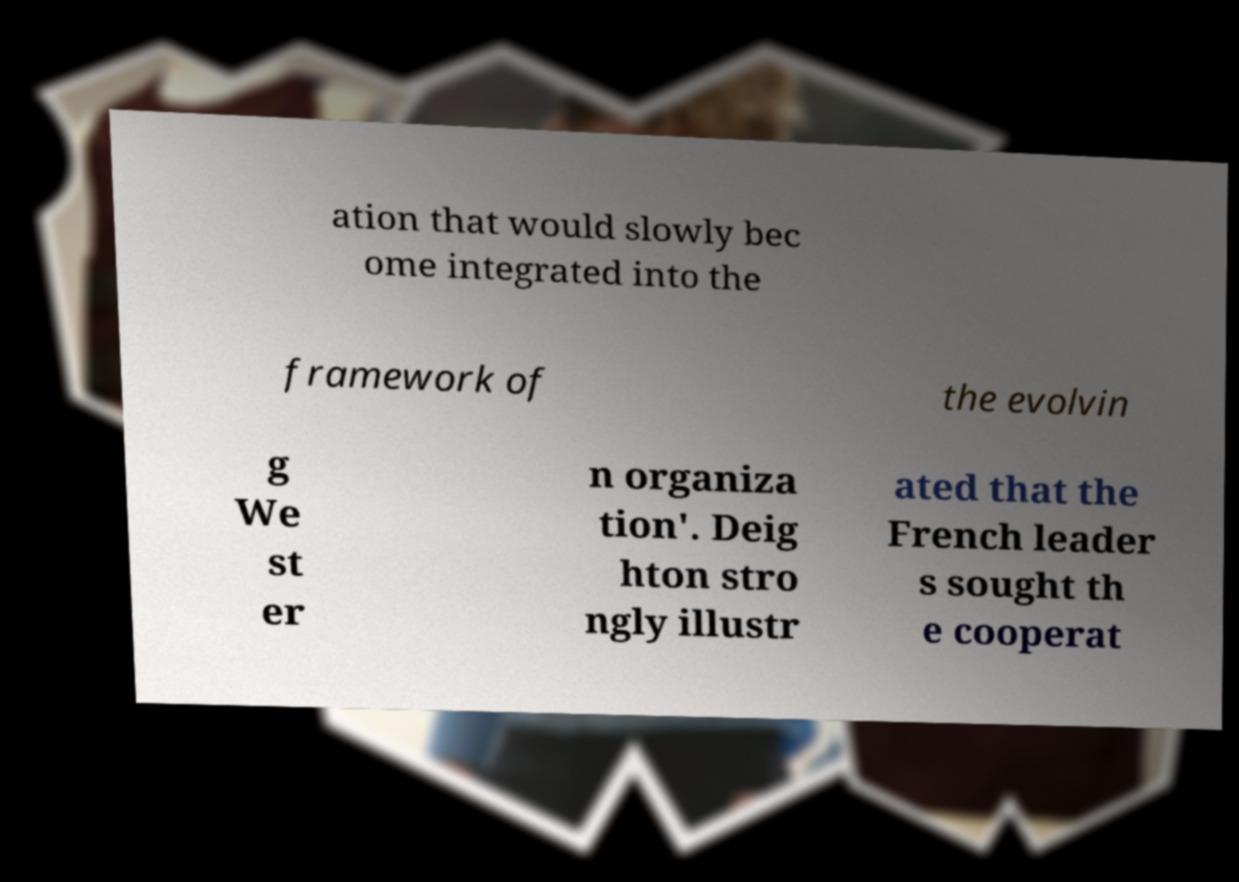Can you accurately transcribe the text from the provided image for me? ation that would slowly bec ome integrated into the framework of the evolvin g We st er n organiza tion'. Deig hton stro ngly illustr ated that the French leader s sought th e cooperat 